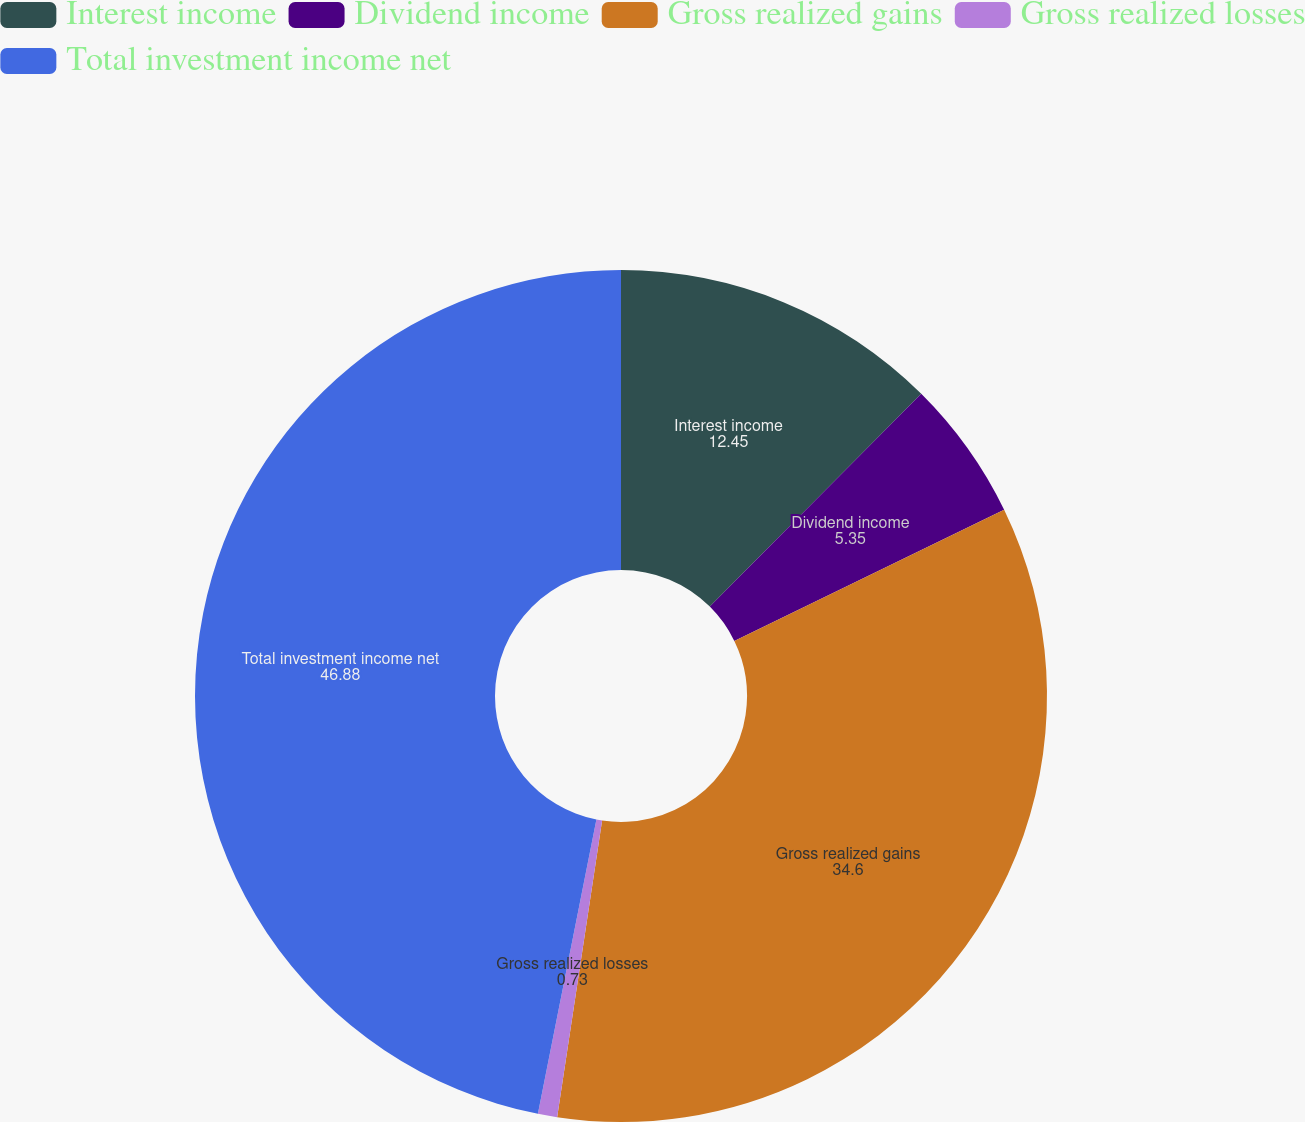Convert chart to OTSL. <chart><loc_0><loc_0><loc_500><loc_500><pie_chart><fcel>Interest income<fcel>Dividend income<fcel>Gross realized gains<fcel>Gross realized losses<fcel>Total investment income net<nl><fcel>12.45%<fcel>5.35%<fcel>34.6%<fcel>0.73%<fcel>46.88%<nl></chart> 